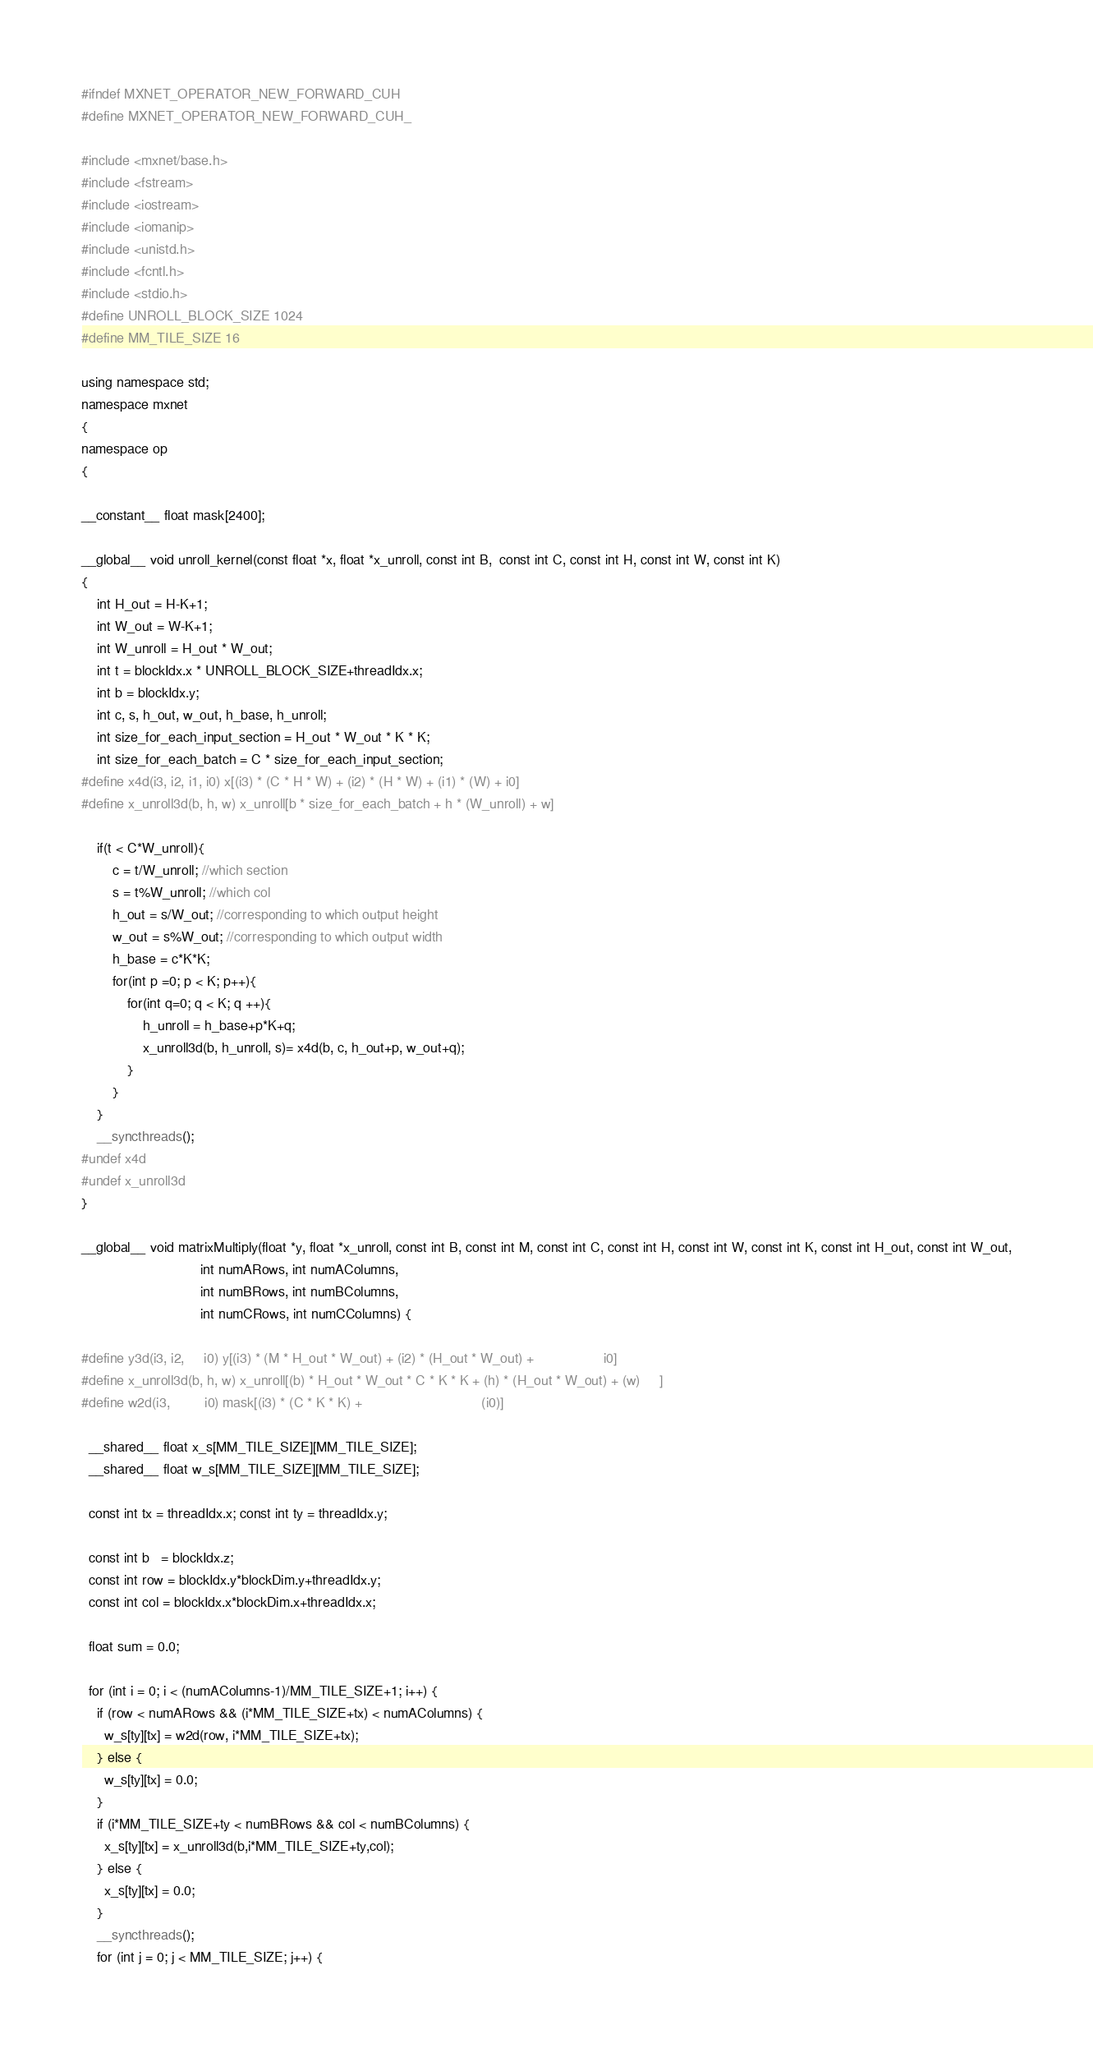<code> <loc_0><loc_0><loc_500><loc_500><_Cuda_>#ifndef MXNET_OPERATOR_NEW_FORWARD_CUH
#define MXNET_OPERATOR_NEW_FORWARD_CUH_

#include <mxnet/base.h>
#include <fstream>
#include <iostream>
#include <iomanip>
#include <unistd.h>
#include <fcntl.h>
#include <stdio.h>
#define UNROLL_BLOCK_SIZE 1024
#define MM_TILE_SIZE 16

using namespace std;
namespace mxnet
{
namespace op
{

__constant__ float mask[2400];

__global__ void unroll_kernel(const float *x, float *x_unroll, const int B,  const int C, const int H, const int W, const int K)
{
    int H_out = H-K+1;
    int W_out = W-K+1;
    int W_unroll = H_out * W_out;
    int t = blockIdx.x * UNROLL_BLOCK_SIZE+threadIdx.x;
    int b = blockIdx.y;
    int c, s, h_out, w_out, h_base, h_unroll;
    int size_for_each_input_section = H_out * W_out * K * K;
    int size_for_each_batch = C * size_for_each_input_section;
#define x4d(i3, i2, i1, i0) x[(i3) * (C * H * W) + (i2) * (H * W) + (i1) * (W) + i0]
#define x_unroll3d(b, h, w) x_unroll[b * size_for_each_batch + h * (W_unroll) + w]

    if(t < C*W_unroll){
        c = t/W_unroll; //which section
        s = t%W_unroll; //which col
        h_out = s/W_out; //corresponding to which output height
        w_out = s%W_out; //corresponding to which output width
        h_base = c*K*K; 
        for(int p =0; p < K; p++){
            for(int q=0; q < K; q ++){
                h_unroll = h_base+p*K+q;
                x_unroll3d(b, h_unroll, s)= x4d(b, c, h_out+p, w_out+q);
            }
        }
    }
    __syncthreads();
#undef x4d
#undef x_unroll3d
}

__global__ void matrixMultiply(float *y, float *x_unroll, const int B, const int M, const int C, const int H, const int W, const int K, const int H_out, const int W_out,
                               int numARows, int numAColumns,
                               int numBRows, int numBColumns,
                               int numCRows, int numCColumns) {

#define y3d(i3, i2,     i0) y[(i3) * (M * H_out * W_out) + (i2) * (H_out * W_out) +                  i0]
#define x_unroll3d(b, h, w) x_unroll[(b) * H_out * W_out * C * K * K + (h) * (H_out * W_out) + (w)     ]
#define w2d(i3,         i0) mask[(i3) * (C * K * K) +                               (i0)]

  __shared__ float x_s[MM_TILE_SIZE][MM_TILE_SIZE];
  __shared__ float w_s[MM_TILE_SIZE][MM_TILE_SIZE];

  const int tx = threadIdx.x; const int ty = threadIdx.y;

  const int b   = blockIdx.z;
  const int row = blockIdx.y*blockDim.y+threadIdx.y;
  const int col = blockIdx.x*blockDim.x+threadIdx.x;

  float sum = 0.0;

  for (int i = 0; i < (numAColumns-1)/MM_TILE_SIZE+1; i++) {
    if (row < numARows && (i*MM_TILE_SIZE+tx) < numAColumns) {
      w_s[ty][tx] = w2d(row, i*MM_TILE_SIZE+tx);
    } else {
      w_s[ty][tx] = 0.0;
    }
    if (i*MM_TILE_SIZE+ty < numBRows && col < numBColumns) {
      x_s[ty][tx] = x_unroll3d(b,i*MM_TILE_SIZE+ty,col);
    } else {
      x_s[ty][tx] = 0.0;
    }
    __syncthreads();
    for (int j = 0; j < MM_TILE_SIZE; j++) {</code> 